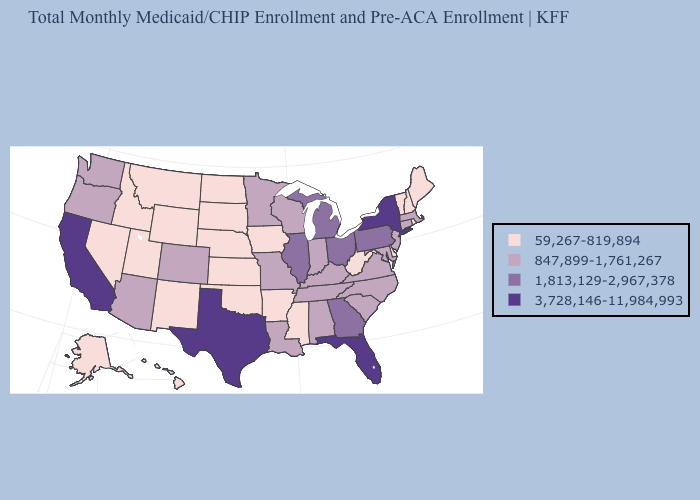Among the states that border Missouri , does Oklahoma have the lowest value?
Short answer required. Yes. What is the lowest value in the USA?
Short answer required. 59,267-819,894. What is the value of Kentucky?
Answer briefly. 847,899-1,761,267. Does Montana have a higher value than New York?
Keep it brief. No. Does Arizona have the highest value in the USA?
Give a very brief answer. No. Does Tennessee have the lowest value in the USA?
Quick response, please. No. What is the highest value in the West ?
Answer briefly. 3,728,146-11,984,993. Which states have the highest value in the USA?
Short answer required. California, Florida, New York, Texas. Does the first symbol in the legend represent the smallest category?
Give a very brief answer. Yes. Does New York have the highest value in the Northeast?
Write a very short answer. Yes. Among the states that border Washington , which have the highest value?
Concise answer only. Oregon. What is the lowest value in the Northeast?
Be succinct. 59,267-819,894. What is the lowest value in the USA?
Concise answer only. 59,267-819,894. Name the states that have a value in the range 59,267-819,894?
Concise answer only. Alaska, Arkansas, Delaware, Hawaii, Idaho, Iowa, Kansas, Maine, Mississippi, Montana, Nebraska, Nevada, New Hampshire, New Mexico, North Dakota, Oklahoma, Rhode Island, South Dakota, Utah, Vermont, West Virginia, Wyoming. Name the states that have a value in the range 1,813,129-2,967,378?
Concise answer only. Georgia, Illinois, Michigan, Ohio, Pennsylvania. 